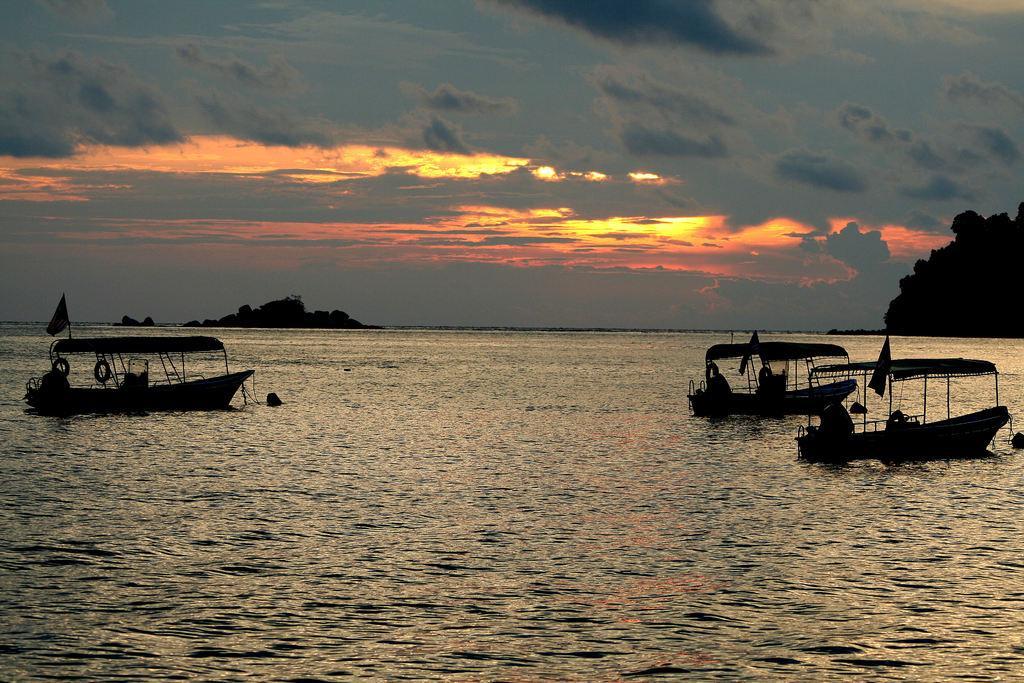Can you describe this image briefly? In this picture there are boats on the right and left side of the image on the water and there are trees in the background area of the image. 